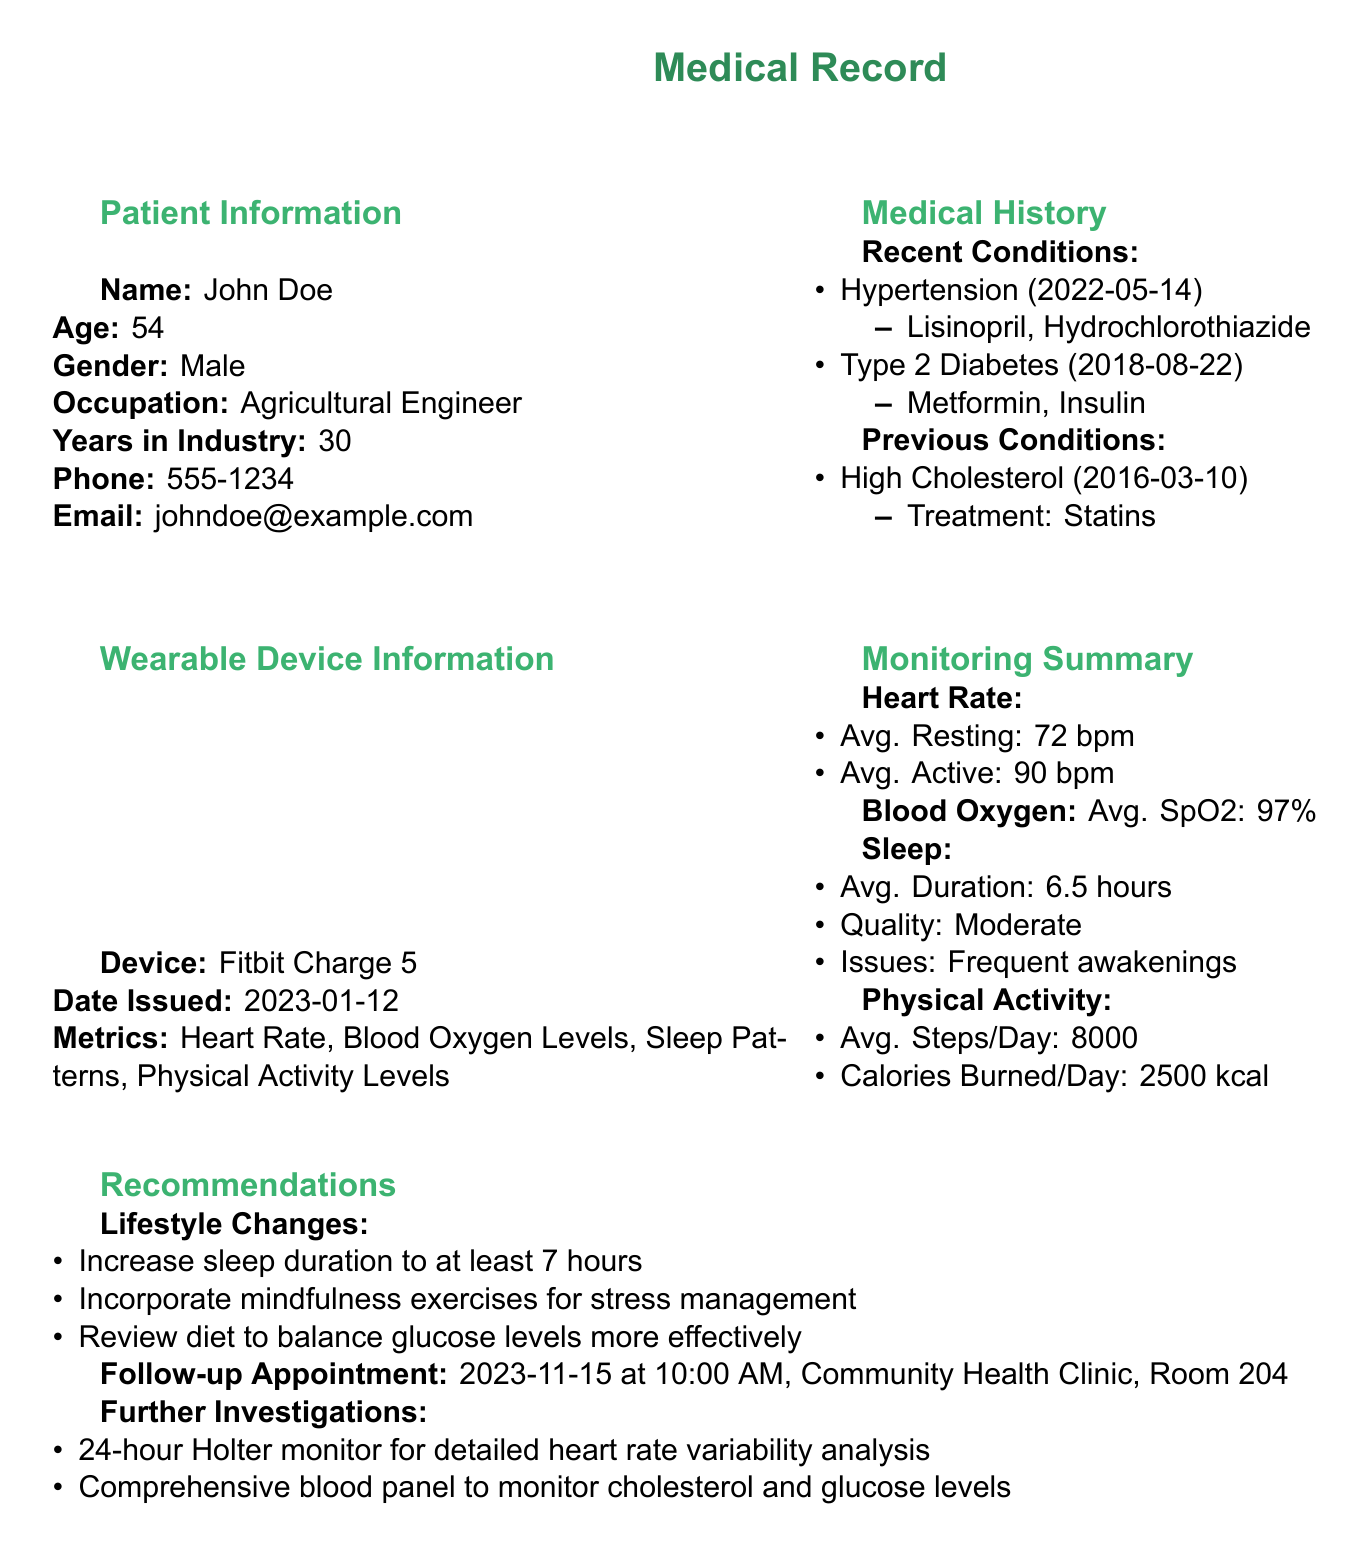What is the patient's name? The patient's name is mentioned in the Patient Information section of the document.
Answer: John Doe What is the date of the follow-up appointment? The follow-up appointment date is listed under the Recommendations section.
Answer: 2023-11-15 What is the blood oxygen level recorded? The average blood oxygen level is specified in the Monitoring Summary section.
Answer: 97% How many steps does the patient average per day? The average steps per day is found in the Physical Activity subsection of the Monitoring Summary.
Answer: 8000 What medications does the patient take for Type 2 Diabetes? The medications for Type 2 Diabetes are listed in the Recent Conditions section of the Medical History.
Answer: Metformin, Insulin What lifestyle change is recommended for better sleep? The Recommendations section suggests an increase in sleep duration.
Answer: Increase sleep duration to at least 7 hours What is the average resting heart rate recorded? The average resting heart rate is presented in the Monitoring Summary under Heart Rate.
Answer: 72 bpm What is the patient's profession? The patient's occupation is mentioned in the Patient Information section.
Answer: Agricultural Engineer What is one of the issues reported in the patient's sleep patterns? The issues reported in sleep patterns can be found in the Monitoring Summary section.
Answer: Frequent awakenings 